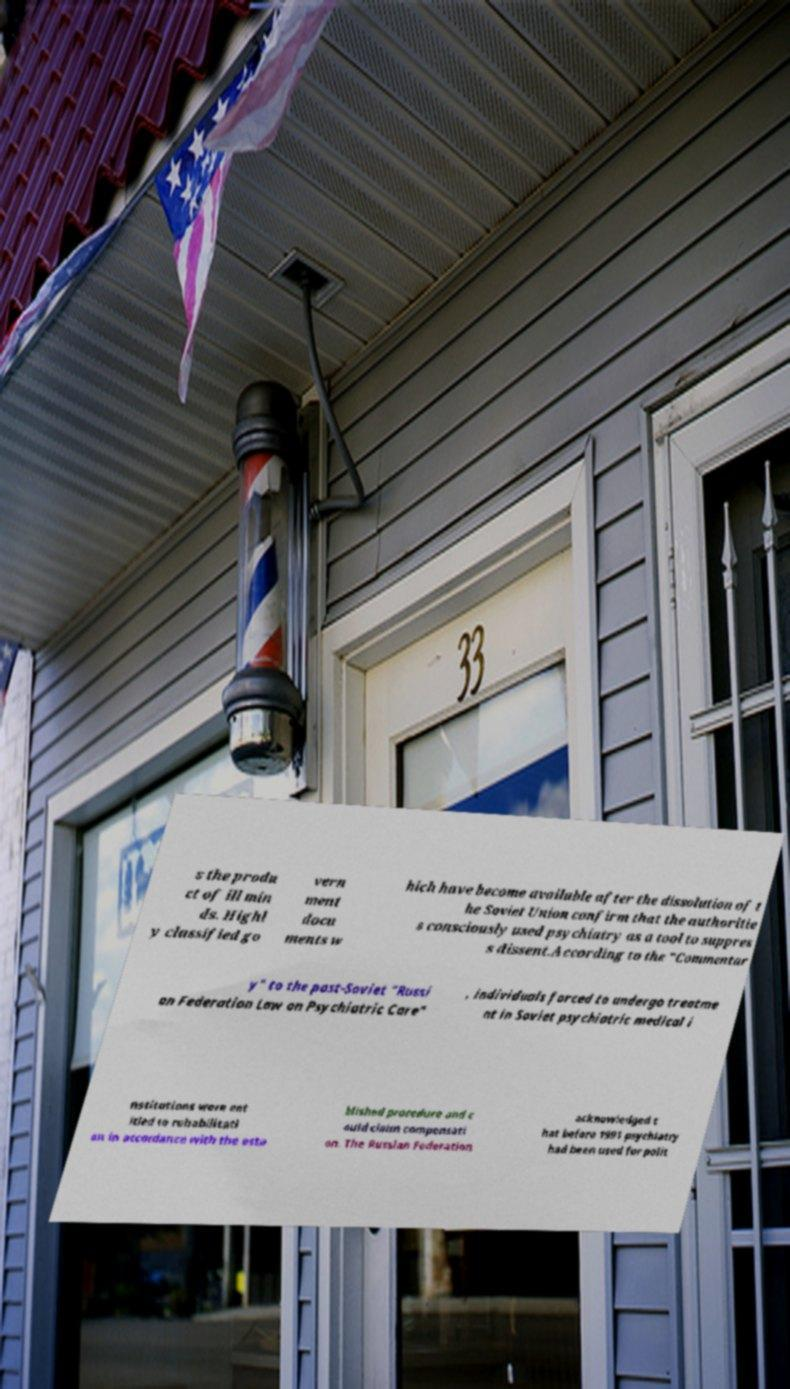Please identify and transcribe the text found in this image. s the produ ct of ill min ds. Highl y classified go vern ment docu ments w hich have become available after the dissolution of t he Soviet Union confirm that the authoritie s consciously used psychiatry as a tool to suppres s dissent.According to the "Commentar y" to the post-Soviet "Russi an Federation Law on Psychiatric Care" , individuals forced to undergo treatme nt in Soviet psychiatric medical i nstitutions were ent itled to rehabilitati on in accordance with the esta blished procedure and c ould claim compensati on. The Russian Federation acknowledged t hat before 1991 psychiatry had been used for polit 